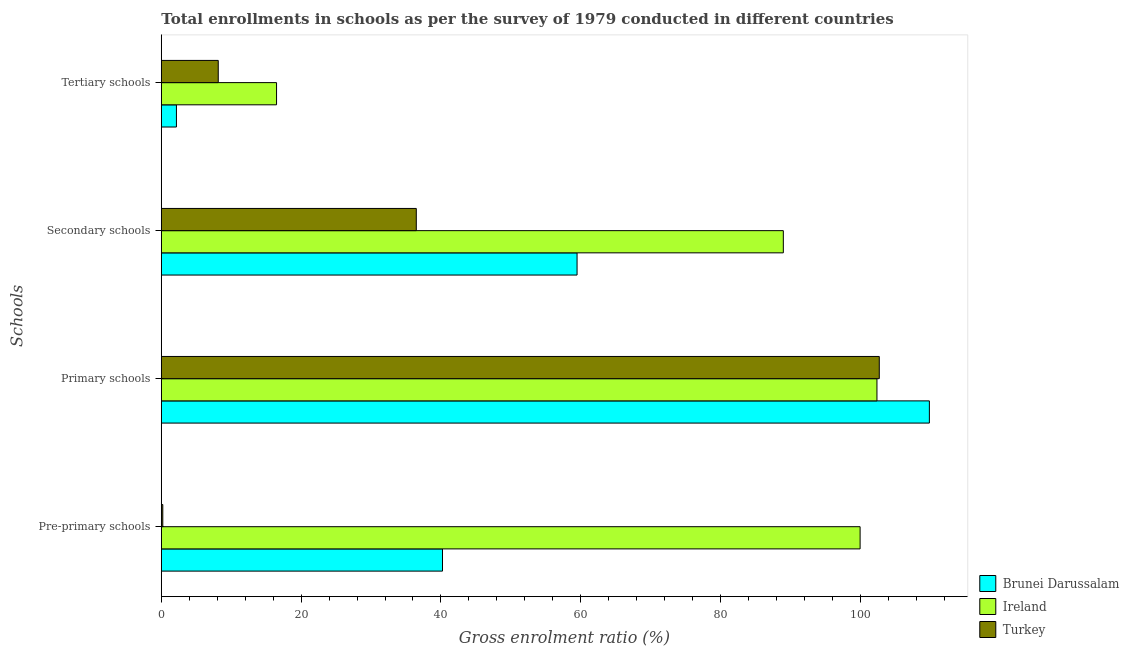How many bars are there on the 4th tick from the top?
Ensure brevity in your answer.  3. How many bars are there on the 4th tick from the bottom?
Ensure brevity in your answer.  3. What is the label of the 1st group of bars from the top?
Provide a succinct answer. Tertiary schools. What is the gross enrolment ratio in primary schools in Ireland?
Offer a terse response. 102.37. Across all countries, what is the maximum gross enrolment ratio in pre-primary schools?
Your answer should be compact. 99.96. Across all countries, what is the minimum gross enrolment ratio in pre-primary schools?
Your response must be concise. 0.21. In which country was the gross enrolment ratio in tertiary schools maximum?
Provide a short and direct response. Ireland. In which country was the gross enrolment ratio in secondary schools minimum?
Offer a very short reply. Turkey. What is the total gross enrolment ratio in secondary schools in the graph?
Ensure brevity in your answer.  184.92. What is the difference between the gross enrolment ratio in pre-primary schools in Brunei Darussalam and that in Ireland?
Offer a very short reply. -59.74. What is the difference between the gross enrolment ratio in tertiary schools in Ireland and the gross enrolment ratio in secondary schools in Brunei Darussalam?
Your answer should be very brief. -42.99. What is the average gross enrolment ratio in primary schools per country?
Your response must be concise. 104.98. What is the difference between the gross enrolment ratio in secondary schools and gross enrolment ratio in pre-primary schools in Turkey?
Provide a short and direct response. 36.26. In how many countries, is the gross enrolment ratio in pre-primary schools greater than 60 %?
Ensure brevity in your answer.  1. What is the ratio of the gross enrolment ratio in secondary schools in Ireland to that in Brunei Darussalam?
Make the answer very short. 1.5. What is the difference between the highest and the second highest gross enrolment ratio in tertiary schools?
Offer a very short reply. 8.34. What is the difference between the highest and the lowest gross enrolment ratio in secondary schools?
Give a very brief answer. 52.5. Is it the case that in every country, the sum of the gross enrolment ratio in secondary schools and gross enrolment ratio in primary schools is greater than the sum of gross enrolment ratio in pre-primary schools and gross enrolment ratio in tertiary schools?
Your answer should be very brief. Yes. What does the 3rd bar from the top in Tertiary schools represents?
Your response must be concise. Brunei Darussalam. What does the 1st bar from the bottom in Secondary schools represents?
Provide a succinct answer. Brunei Darussalam. How many bars are there?
Provide a short and direct response. 12. What is the difference between two consecutive major ticks on the X-axis?
Keep it short and to the point. 20. Are the values on the major ticks of X-axis written in scientific E-notation?
Keep it short and to the point. No. Does the graph contain any zero values?
Make the answer very short. No. Where does the legend appear in the graph?
Your answer should be very brief. Bottom right. How are the legend labels stacked?
Provide a short and direct response. Vertical. What is the title of the graph?
Your answer should be very brief. Total enrollments in schools as per the survey of 1979 conducted in different countries. Does "Djibouti" appear as one of the legend labels in the graph?
Make the answer very short. No. What is the label or title of the X-axis?
Your response must be concise. Gross enrolment ratio (%). What is the label or title of the Y-axis?
Ensure brevity in your answer.  Schools. What is the Gross enrolment ratio (%) in Brunei Darussalam in Pre-primary schools?
Give a very brief answer. 40.22. What is the Gross enrolment ratio (%) of Ireland in Pre-primary schools?
Provide a short and direct response. 99.96. What is the Gross enrolment ratio (%) of Turkey in Pre-primary schools?
Your answer should be compact. 0.21. What is the Gross enrolment ratio (%) of Brunei Darussalam in Primary schools?
Offer a terse response. 109.87. What is the Gross enrolment ratio (%) in Ireland in Primary schools?
Your answer should be compact. 102.37. What is the Gross enrolment ratio (%) in Turkey in Primary schools?
Offer a terse response. 102.7. What is the Gross enrolment ratio (%) of Brunei Darussalam in Secondary schools?
Provide a short and direct response. 59.47. What is the Gross enrolment ratio (%) in Ireland in Secondary schools?
Offer a very short reply. 88.98. What is the Gross enrolment ratio (%) in Turkey in Secondary schools?
Your answer should be compact. 36.47. What is the Gross enrolment ratio (%) in Brunei Darussalam in Tertiary schools?
Your response must be concise. 2.16. What is the Gross enrolment ratio (%) of Ireland in Tertiary schools?
Make the answer very short. 16.48. What is the Gross enrolment ratio (%) of Turkey in Tertiary schools?
Provide a succinct answer. 8.14. Across all Schools, what is the maximum Gross enrolment ratio (%) of Brunei Darussalam?
Offer a very short reply. 109.87. Across all Schools, what is the maximum Gross enrolment ratio (%) in Ireland?
Provide a succinct answer. 102.37. Across all Schools, what is the maximum Gross enrolment ratio (%) of Turkey?
Keep it short and to the point. 102.7. Across all Schools, what is the minimum Gross enrolment ratio (%) of Brunei Darussalam?
Make the answer very short. 2.16. Across all Schools, what is the minimum Gross enrolment ratio (%) in Ireland?
Offer a terse response. 16.48. Across all Schools, what is the minimum Gross enrolment ratio (%) in Turkey?
Keep it short and to the point. 0.21. What is the total Gross enrolment ratio (%) of Brunei Darussalam in the graph?
Keep it short and to the point. 211.72. What is the total Gross enrolment ratio (%) in Ireland in the graph?
Keep it short and to the point. 307.79. What is the total Gross enrolment ratio (%) of Turkey in the graph?
Your answer should be compact. 147.53. What is the difference between the Gross enrolment ratio (%) in Brunei Darussalam in Pre-primary schools and that in Primary schools?
Provide a succinct answer. -69.64. What is the difference between the Gross enrolment ratio (%) of Ireland in Pre-primary schools and that in Primary schools?
Offer a very short reply. -2.41. What is the difference between the Gross enrolment ratio (%) in Turkey in Pre-primary schools and that in Primary schools?
Provide a succinct answer. -102.49. What is the difference between the Gross enrolment ratio (%) of Brunei Darussalam in Pre-primary schools and that in Secondary schools?
Your answer should be compact. -19.25. What is the difference between the Gross enrolment ratio (%) of Ireland in Pre-primary schools and that in Secondary schools?
Make the answer very short. 10.98. What is the difference between the Gross enrolment ratio (%) in Turkey in Pre-primary schools and that in Secondary schools?
Provide a short and direct response. -36.26. What is the difference between the Gross enrolment ratio (%) of Brunei Darussalam in Pre-primary schools and that in Tertiary schools?
Your answer should be compact. 38.06. What is the difference between the Gross enrolment ratio (%) of Ireland in Pre-primary schools and that in Tertiary schools?
Your response must be concise. 83.47. What is the difference between the Gross enrolment ratio (%) in Turkey in Pre-primary schools and that in Tertiary schools?
Offer a very short reply. -7.93. What is the difference between the Gross enrolment ratio (%) in Brunei Darussalam in Primary schools and that in Secondary schools?
Ensure brevity in your answer.  50.4. What is the difference between the Gross enrolment ratio (%) of Ireland in Primary schools and that in Secondary schools?
Your answer should be compact. 13.39. What is the difference between the Gross enrolment ratio (%) in Turkey in Primary schools and that in Secondary schools?
Keep it short and to the point. 66.23. What is the difference between the Gross enrolment ratio (%) in Brunei Darussalam in Primary schools and that in Tertiary schools?
Offer a terse response. 107.7. What is the difference between the Gross enrolment ratio (%) in Ireland in Primary schools and that in Tertiary schools?
Your response must be concise. 85.89. What is the difference between the Gross enrolment ratio (%) in Turkey in Primary schools and that in Tertiary schools?
Provide a short and direct response. 94.56. What is the difference between the Gross enrolment ratio (%) in Brunei Darussalam in Secondary schools and that in Tertiary schools?
Provide a short and direct response. 57.31. What is the difference between the Gross enrolment ratio (%) in Ireland in Secondary schools and that in Tertiary schools?
Offer a very short reply. 72.49. What is the difference between the Gross enrolment ratio (%) in Turkey in Secondary schools and that in Tertiary schools?
Keep it short and to the point. 28.33. What is the difference between the Gross enrolment ratio (%) in Brunei Darussalam in Pre-primary schools and the Gross enrolment ratio (%) in Ireland in Primary schools?
Your response must be concise. -62.15. What is the difference between the Gross enrolment ratio (%) of Brunei Darussalam in Pre-primary schools and the Gross enrolment ratio (%) of Turkey in Primary schools?
Keep it short and to the point. -62.48. What is the difference between the Gross enrolment ratio (%) of Ireland in Pre-primary schools and the Gross enrolment ratio (%) of Turkey in Primary schools?
Your answer should be very brief. -2.74. What is the difference between the Gross enrolment ratio (%) in Brunei Darussalam in Pre-primary schools and the Gross enrolment ratio (%) in Ireland in Secondary schools?
Make the answer very short. -48.75. What is the difference between the Gross enrolment ratio (%) in Brunei Darussalam in Pre-primary schools and the Gross enrolment ratio (%) in Turkey in Secondary schools?
Offer a terse response. 3.75. What is the difference between the Gross enrolment ratio (%) of Ireland in Pre-primary schools and the Gross enrolment ratio (%) of Turkey in Secondary schools?
Offer a terse response. 63.49. What is the difference between the Gross enrolment ratio (%) in Brunei Darussalam in Pre-primary schools and the Gross enrolment ratio (%) in Ireland in Tertiary schools?
Ensure brevity in your answer.  23.74. What is the difference between the Gross enrolment ratio (%) of Brunei Darussalam in Pre-primary schools and the Gross enrolment ratio (%) of Turkey in Tertiary schools?
Your answer should be very brief. 32.08. What is the difference between the Gross enrolment ratio (%) of Ireland in Pre-primary schools and the Gross enrolment ratio (%) of Turkey in Tertiary schools?
Offer a very short reply. 91.81. What is the difference between the Gross enrolment ratio (%) in Brunei Darussalam in Primary schools and the Gross enrolment ratio (%) in Ireland in Secondary schools?
Give a very brief answer. 20.89. What is the difference between the Gross enrolment ratio (%) of Brunei Darussalam in Primary schools and the Gross enrolment ratio (%) of Turkey in Secondary schools?
Provide a succinct answer. 73.39. What is the difference between the Gross enrolment ratio (%) of Ireland in Primary schools and the Gross enrolment ratio (%) of Turkey in Secondary schools?
Ensure brevity in your answer.  65.9. What is the difference between the Gross enrolment ratio (%) of Brunei Darussalam in Primary schools and the Gross enrolment ratio (%) of Ireland in Tertiary schools?
Your response must be concise. 93.38. What is the difference between the Gross enrolment ratio (%) of Brunei Darussalam in Primary schools and the Gross enrolment ratio (%) of Turkey in Tertiary schools?
Ensure brevity in your answer.  101.72. What is the difference between the Gross enrolment ratio (%) of Ireland in Primary schools and the Gross enrolment ratio (%) of Turkey in Tertiary schools?
Give a very brief answer. 94.22. What is the difference between the Gross enrolment ratio (%) in Brunei Darussalam in Secondary schools and the Gross enrolment ratio (%) in Ireland in Tertiary schools?
Provide a short and direct response. 42.99. What is the difference between the Gross enrolment ratio (%) of Brunei Darussalam in Secondary schools and the Gross enrolment ratio (%) of Turkey in Tertiary schools?
Your answer should be compact. 51.32. What is the difference between the Gross enrolment ratio (%) of Ireland in Secondary schools and the Gross enrolment ratio (%) of Turkey in Tertiary schools?
Provide a short and direct response. 80.83. What is the average Gross enrolment ratio (%) in Brunei Darussalam per Schools?
Your answer should be compact. 52.93. What is the average Gross enrolment ratio (%) in Ireland per Schools?
Provide a succinct answer. 76.95. What is the average Gross enrolment ratio (%) in Turkey per Schools?
Provide a succinct answer. 36.88. What is the difference between the Gross enrolment ratio (%) in Brunei Darussalam and Gross enrolment ratio (%) in Ireland in Pre-primary schools?
Provide a succinct answer. -59.74. What is the difference between the Gross enrolment ratio (%) in Brunei Darussalam and Gross enrolment ratio (%) in Turkey in Pre-primary schools?
Your response must be concise. 40.01. What is the difference between the Gross enrolment ratio (%) in Ireland and Gross enrolment ratio (%) in Turkey in Pre-primary schools?
Provide a short and direct response. 99.75. What is the difference between the Gross enrolment ratio (%) of Brunei Darussalam and Gross enrolment ratio (%) of Ireland in Primary schools?
Ensure brevity in your answer.  7.5. What is the difference between the Gross enrolment ratio (%) in Brunei Darussalam and Gross enrolment ratio (%) in Turkey in Primary schools?
Give a very brief answer. 7.17. What is the difference between the Gross enrolment ratio (%) in Ireland and Gross enrolment ratio (%) in Turkey in Primary schools?
Give a very brief answer. -0.33. What is the difference between the Gross enrolment ratio (%) in Brunei Darussalam and Gross enrolment ratio (%) in Ireland in Secondary schools?
Make the answer very short. -29.51. What is the difference between the Gross enrolment ratio (%) in Brunei Darussalam and Gross enrolment ratio (%) in Turkey in Secondary schools?
Give a very brief answer. 23. What is the difference between the Gross enrolment ratio (%) of Ireland and Gross enrolment ratio (%) of Turkey in Secondary schools?
Your answer should be very brief. 52.5. What is the difference between the Gross enrolment ratio (%) in Brunei Darussalam and Gross enrolment ratio (%) in Ireland in Tertiary schools?
Ensure brevity in your answer.  -14.32. What is the difference between the Gross enrolment ratio (%) of Brunei Darussalam and Gross enrolment ratio (%) of Turkey in Tertiary schools?
Offer a terse response. -5.98. What is the difference between the Gross enrolment ratio (%) of Ireland and Gross enrolment ratio (%) of Turkey in Tertiary schools?
Offer a terse response. 8.34. What is the ratio of the Gross enrolment ratio (%) in Brunei Darussalam in Pre-primary schools to that in Primary schools?
Offer a very short reply. 0.37. What is the ratio of the Gross enrolment ratio (%) of Ireland in Pre-primary schools to that in Primary schools?
Provide a short and direct response. 0.98. What is the ratio of the Gross enrolment ratio (%) of Turkey in Pre-primary schools to that in Primary schools?
Offer a terse response. 0. What is the ratio of the Gross enrolment ratio (%) in Brunei Darussalam in Pre-primary schools to that in Secondary schools?
Keep it short and to the point. 0.68. What is the ratio of the Gross enrolment ratio (%) in Ireland in Pre-primary schools to that in Secondary schools?
Provide a short and direct response. 1.12. What is the ratio of the Gross enrolment ratio (%) in Turkey in Pre-primary schools to that in Secondary schools?
Ensure brevity in your answer.  0.01. What is the ratio of the Gross enrolment ratio (%) of Brunei Darussalam in Pre-primary schools to that in Tertiary schools?
Provide a succinct answer. 18.6. What is the ratio of the Gross enrolment ratio (%) in Ireland in Pre-primary schools to that in Tertiary schools?
Make the answer very short. 6.06. What is the ratio of the Gross enrolment ratio (%) in Turkey in Pre-primary schools to that in Tertiary schools?
Make the answer very short. 0.03. What is the ratio of the Gross enrolment ratio (%) of Brunei Darussalam in Primary schools to that in Secondary schools?
Keep it short and to the point. 1.85. What is the ratio of the Gross enrolment ratio (%) of Ireland in Primary schools to that in Secondary schools?
Your response must be concise. 1.15. What is the ratio of the Gross enrolment ratio (%) of Turkey in Primary schools to that in Secondary schools?
Your answer should be very brief. 2.82. What is the ratio of the Gross enrolment ratio (%) in Brunei Darussalam in Primary schools to that in Tertiary schools?
Your answer should be very brief. 50.82. What is the ratio of the Gross enrolment ratio (%) in Ireland in Primary schools to that in Tertiary schools?
Provide a succinct answer. 6.21. What is the ratio of the Gross enrolment ratio (%) in Turkey in Primary schools to that in Tertiary schools?
Offer a terse response. 12.61. What is the ratio of the Gross enrolment ratio (%) of Brunei Darussalam in Secondary schools to that in Tertiary schools?
Offer a terse response. 27.51. What is the ratio of the Gross enrolment ratio (%) of Ireland in Secondary schools to that in Tertiary schools?
Ensure brevity in your answer.  5.4. What is the ratio of the Gross enrolment ratio (%) of Turkey in Secondary schools to that in Tertiary schools?
Make the answer very short. 4.48. What is the difference between the highest and the second highest Gross enrolment ratio (%) of Brunei Darussalam?
Your answer should be very brief. 50.4. What is the difference between the highest and the second highest Gross enrolment ratio (%) in Ireland?
Make the answer very short. 2.41. What is the difference between the highest and the second highest Gross enrolment ratio (%) in Turkey?
Provide a short and direct response. 66.23. What is the difference between the highest and the lowest Gross enrolment ratio (%) of Brunei Darussalam?
Give a very brief answer. 107.7. What is the difference between the highest and the lowest Gross enrolment ratio (%) of Ireland?
Offer a terse response. 85.89. What is the difference between the highest and the lowest Gross enrolment ratio (%) of Turkey?
Your answer should be very brief. 102.49. 